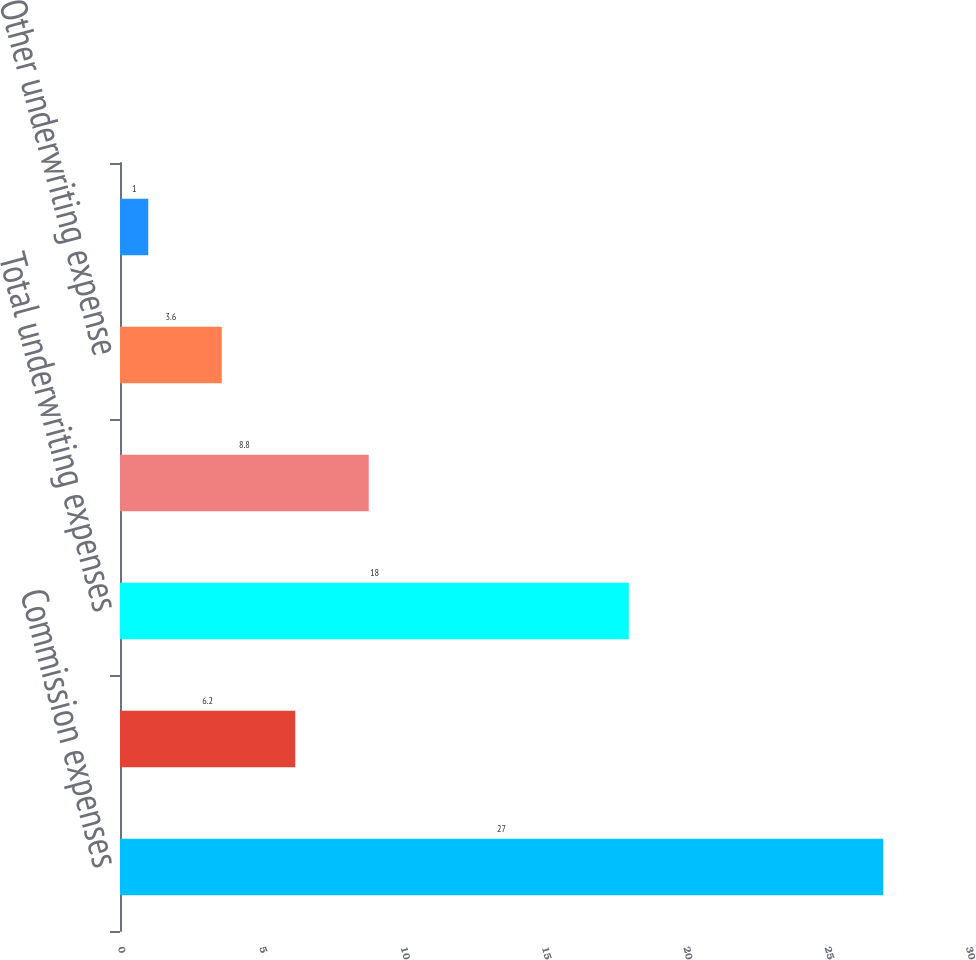<chart> <loc_0><loc_0><loc_500><loc_500><bar_chart><fcel>Commission expenses<fcel>Other underwriting expenses<fcel>Total underwriting expenses<fcel>Commission expense<fcel>Other underwriting expense<fcel>Total underwriting expense<nl><fcel>27<fcel>6.2<fcel>18<fcel>8.8<fcel>3.6<fcel>1<nl></chart> 